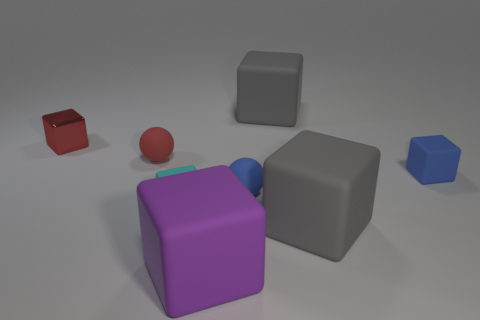What number of small red balls are on the left side of the purple thing?
Offer a terse response. 1. Do the tiny red thing on the right side of the small red cube and the large gray object in front of the tiny cyan thing have the same material?
Ensure brevity in your answer.  Yes. Is the number of cyan blocks that are behind the large purple block greater than the number of tiny blue matte spheres that are left of the shiny thing?
Offer a terse response. Yes. There is a ball that is the same color as the shiny object; what is it made of?
Ensure brevity in your answer.  Rubber. The cube that is both behind the blue ball and to the left of the large purple cube is made of what material?
Provide a short and direct response. Metal. Do the tiny cyan object and the tiny blue object behind the small blue rubber ball have the same material?
Your response must be concise. Yes. What number of things are matte spheres or gray objects that are behind the tiny shiny block?
Your answer should be compact. 3. Do the gray rubber object that is behind the small cyan matte object and the gray thing in front of the tiny metallic object have the same size?
Give a very brief answer. Yes. What number of other objects are there of the same color as the tiny metallic object?
Keep it short and to the point. 1. Is the size of the blue block the same as the gray thing that is behind the blue rubber sphere?
Your answer should be very brief. No. 